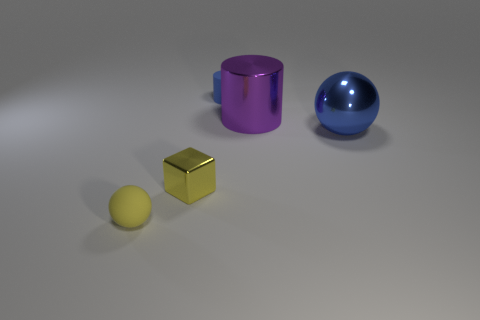Add 3 big brown matte cubes. How many objects exist? 8 Subtract 1 cylinders. How many cylinders are left? 1 Subtract all cylinders. How many objects are left? 3 Subtract all yellow balls. How many purple cylinders are left? 1 Add 4 small matte cylinders. How many small matte cylinders are left? 5 Add 4 metallic spheres. How many metallic spheres exist? 5 Subtract 0 cyan spheres. How many objects are left? 5 Subtract all gray cubes. Subtract all gray spheres. How many cubes are left? 1 Subtract all large metallic spheres. Subtract all tiny rubber objects. How many objects are left? 2 